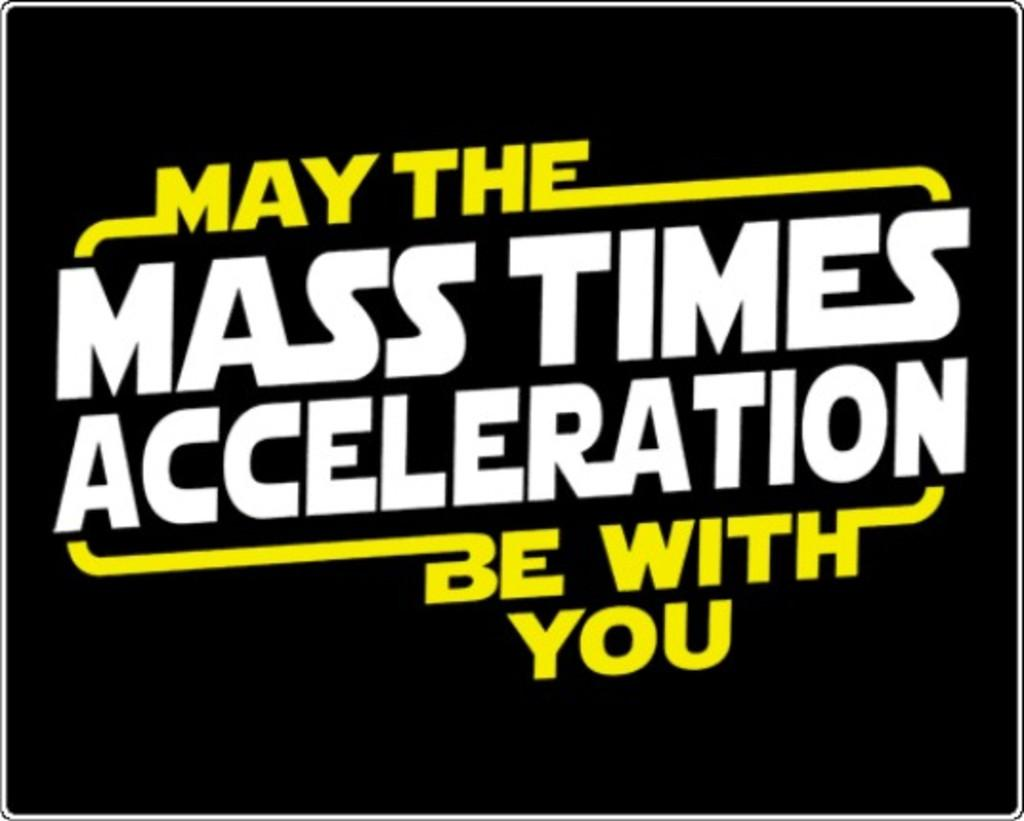Provide a one-sentence caption for the provided image. A star wars joke is displayed on a black background. 